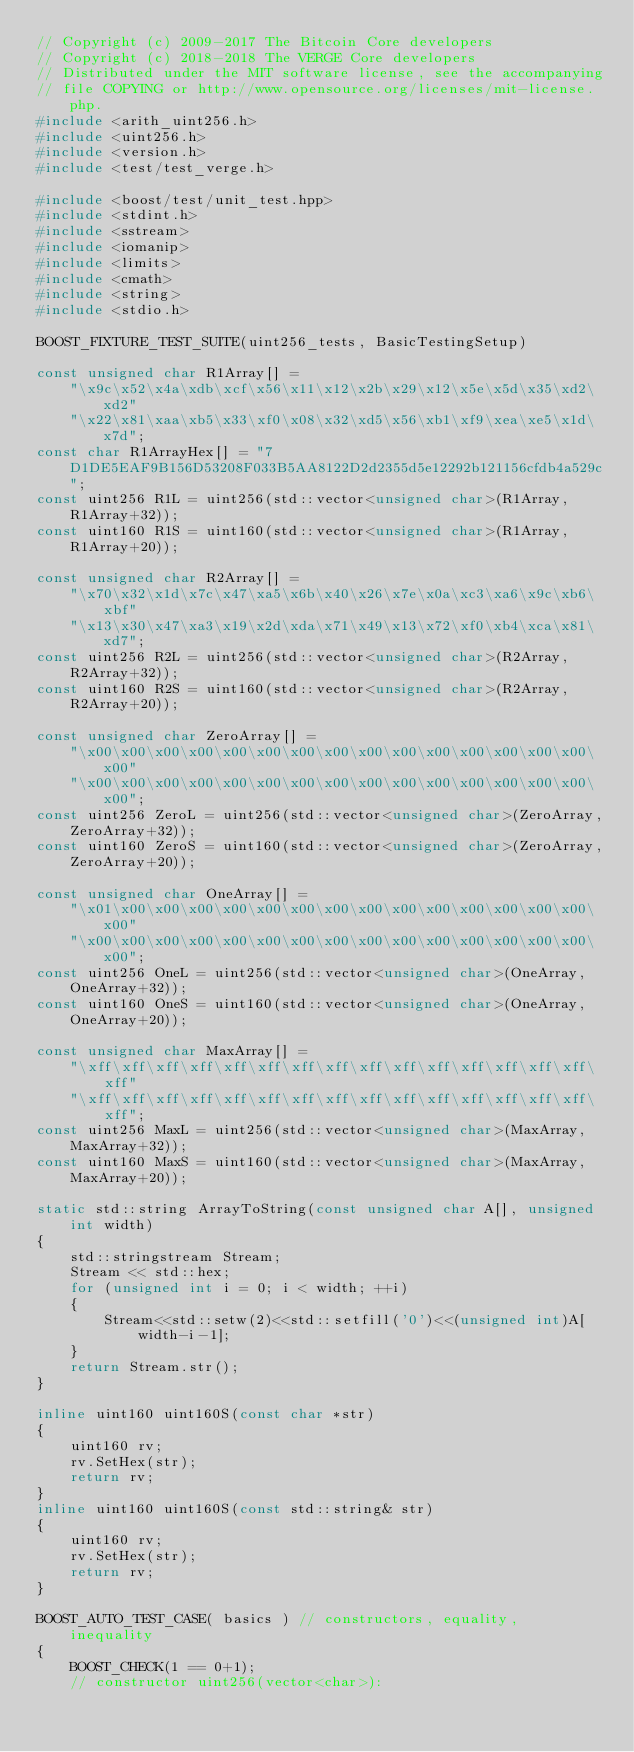Convert code to text. <code><loc_0><loc_0><loc_500><loc_500><_C++_>// Copyright (c) 2009-2017 The Bitcoin Core developers
// Copyright (c) 2018-2018 The VERGE Core developers
// Distributed under the MIT software license, see the accompanying
// file COPYING or http://www.opensource.org/licenses/mit-license.php.
#include <arith_uint256.h>
#include <uint256.h>
#include <version.h>
#include <test/test_verge.h>

#include <boost/test/unit_test.hpp>
#include <stdint.h>
#include <sstream>
#include <iomanip>
#include <limits>
#include <cmath>
#include <string>
#include <stdio.h>

BOOST_FIXTURE_TEST_SUITE(uint256_tests, BasicTestingSetup)

const unsigned char R1Array[] =
    "\x9c\x52\x4a\xdb\xcf\x56\x11\x12\x2b\x29\x12\x5e\x5d\x35\xd2\xd2"
    "\x22\x81\xaa\xb5\x33\xf0\x08\x32\xd5\x56\xb1\xf9\xea\xe5\x1d\x7d";
const char R1ArrayHex[] = "7D1DE5EAF9B156D53208F033B5AA8122D2d2355d5e12292b121156cfdb4a529c";
const uint256 R1L = uint256(std::vector<unsigned char>(R1Array,R1Array+32));
const uint160 R1S = uint160(std::vector<unsigned char>(R1Array,R1Array+20));

const unsigned char R2Array[] =
    "\x70\x32\x1d\x7c\x47\xa5\x6b\x40\x26\x7e\x0a\xc3\xa6\x9c\xb6\xbf"
    "\x13\x30\x47\xa3\x19\x2d\xda\x71\x49\x13\x72\xf0\xb4\xca\x81\xd7";
const uint256 R2L = uint256(std::vector<unsigned char>(R2Array,R2Array+32));
const uint160 R2S = uint160(std::vector<unsigned char>(R2Array,R2Array+20));

const unsigned char ZeroArray[] =
    "\x00\x00\x00\x00\x00\x00\x00\x00\x00\x00\x00\x00\x00\x00\x00\x00"
    "\x00\x00\x00\x00\x00\x00\x00\x00\x00\x00\x00\x00\x00\x00\x00\x00";
const uint256 ZeroL = uint256(std::vector<unsigned char>(ZeroArray,ZeroArray+32));
const uint160 ZeroS = uint160(std::vector<unsigned char>(ZeroArray,ZeroArray+20));

const unsigned char OneArray[] =
    "\x01\x00\x00\x00\x00\x00\x00\x00\x00\x00\x00\x00\x00\x00\x00\x00"
    "\x00\x00\x00\x00\x00\x00\x00\x00\x00\x00\x00\x00\x00\x00\x00\x00";
const uint256 OneL = uint256(std::vector<unsigned char>(OneArray,OneArray+32));
const uint160 OneS = uint160(std::vector<unsigned char>(OneArray,OneArray+20));

const unsigned char MaxArray[] =
    "\xff\xff\xff\xff\xff\xff\xff\xff\xff\xff\xff\xff\xff\xff\xff\xff"
    "\xff\xff\xff\xff\xff\xff\xff\xff\xff\xff\xff\xff\xff\xff\xff\xff";
const uint256 MaxL = uint256(std::vector<unsigned char>(MaxArray,MaxArray+32));
const uint160 MaxS = uint160(std::vector<unsigned char>(MaxArray,MaxArray+20));

static std::string ArrayToString(const unsigned char A[], unsigned int width)
{
    std::stringstream Stream;
    Stream << std::hex;
    for (unsigned int i = 0; i < width; ++i)
    {
        Stream<<std::setw(2)<<std::setfill('0')<<(unsigned int)A[width-i-1];
    }
    return Stream.str();
}

inline uint160 uint160S(const char *str)
{
    uint160 rv;
    rv.SetHex(str);
    return rv;
}
inline uint160 uint160S(const std::string& str)
{
    uint160 rv;
    rv.SetHex(str);
    return rv;
}

BOOST_AUTO_TEST_CASE( basics ) // constructors, equality, inequality
{
    BOOST_CHECK(1 == 0+1);
    // constructor uint256(vector<char>):</code> 